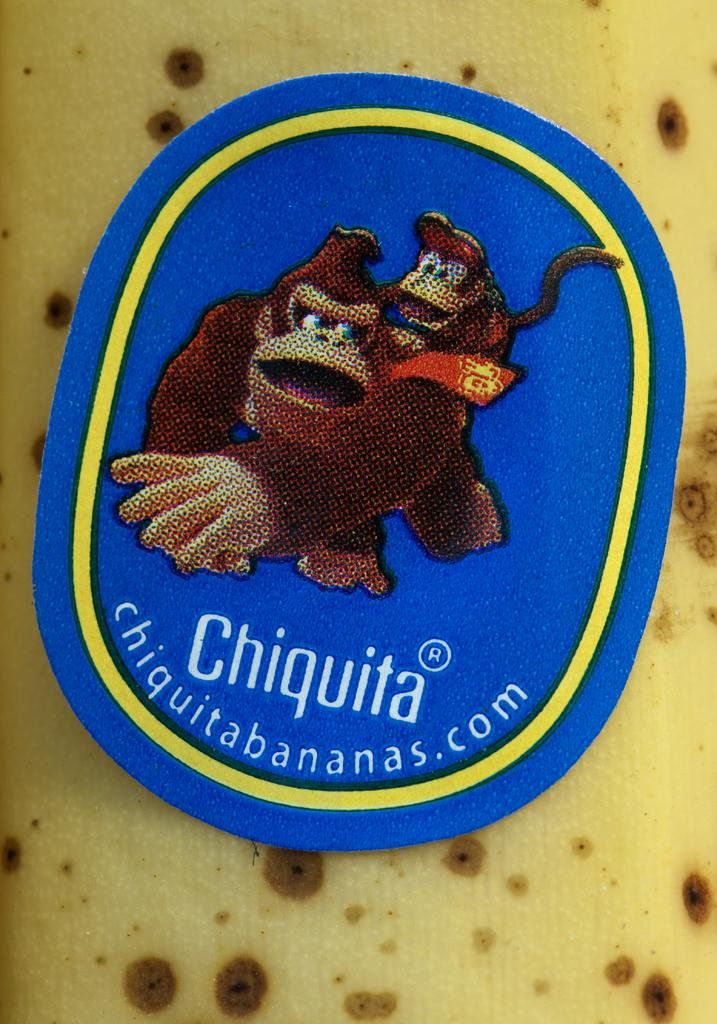What is the main subject of the image? There is an object in the image. What is depicted on the object? The object has a painting of animals. Are there any words or letters on the object? Yes, the object has some text. On what surface is the object placed? The object is placed on a surface. What time of day is it in the image, and is the object rubbing its eyes in the morning? The time of day is not mentioned in the image, and there is no indication that the object is rubbing its eyes or crying. 